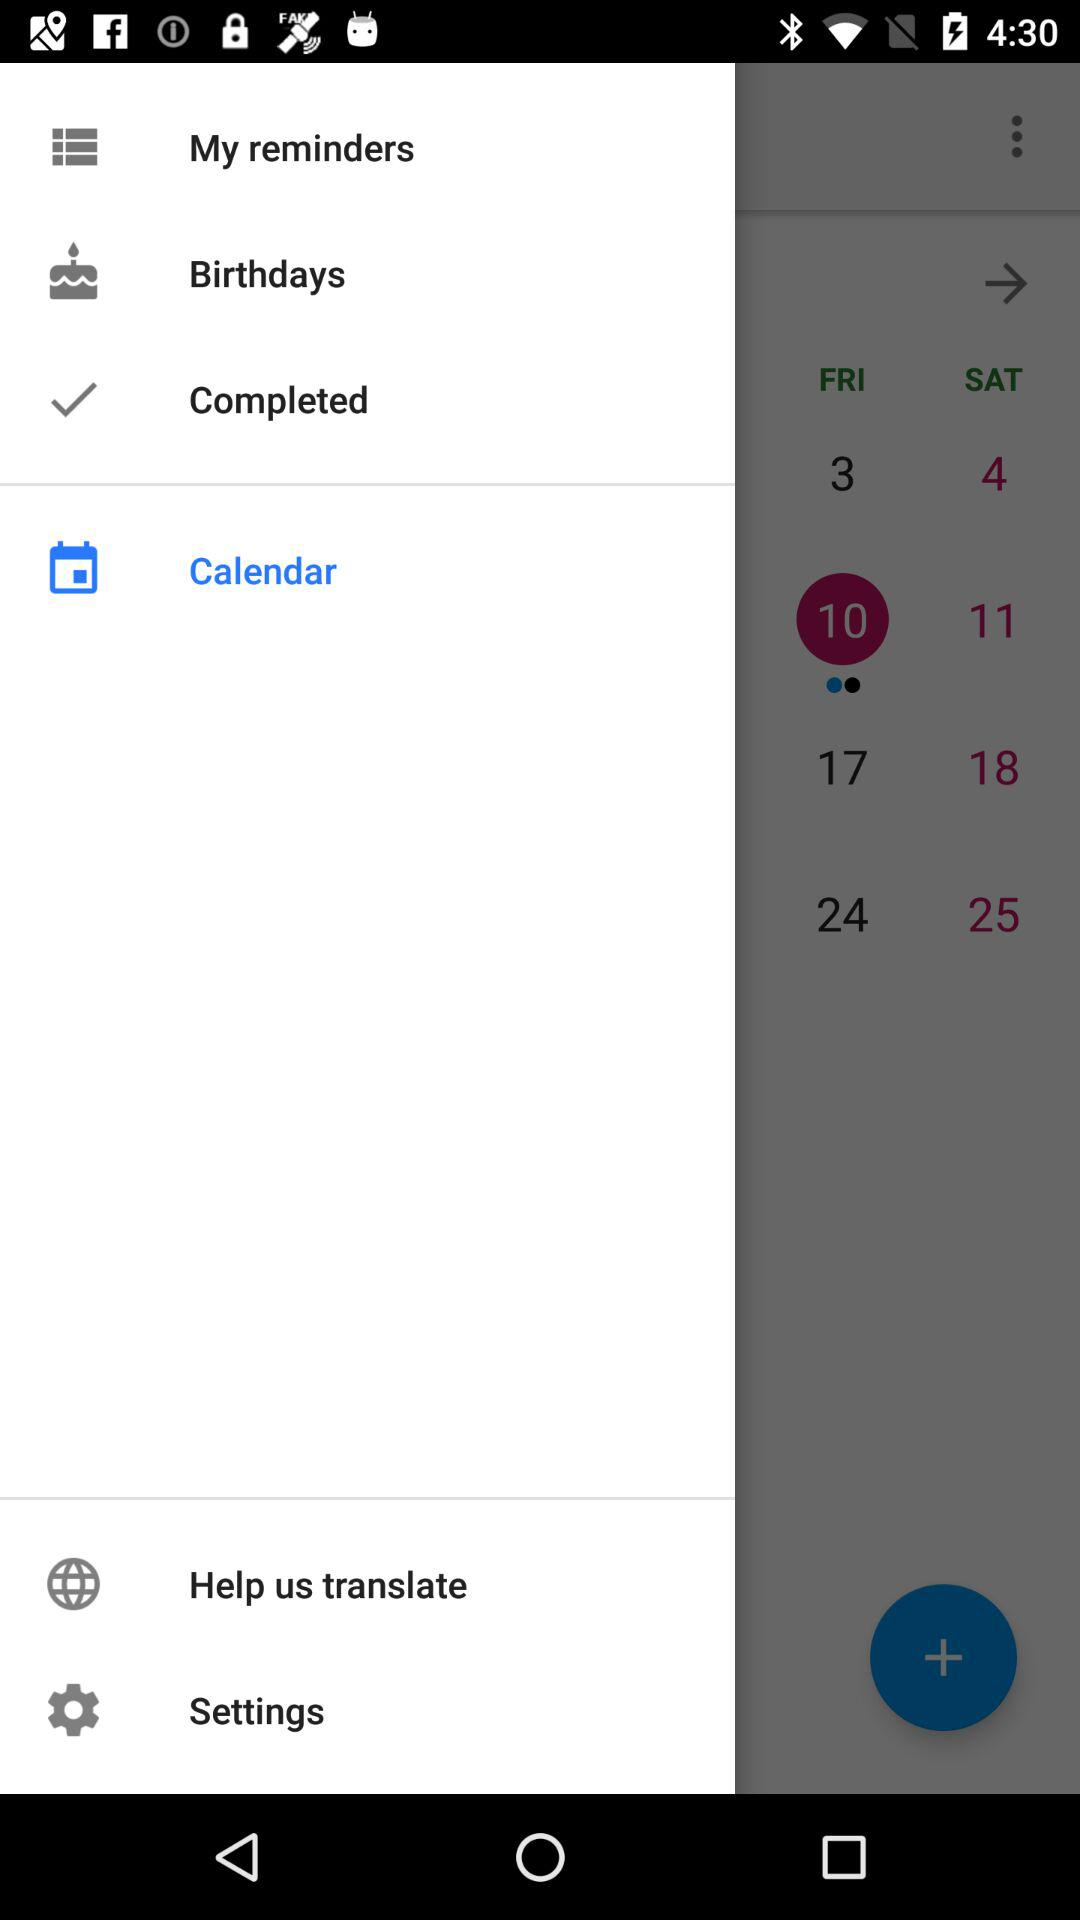What is the day of the selected date? The day is Friday. 